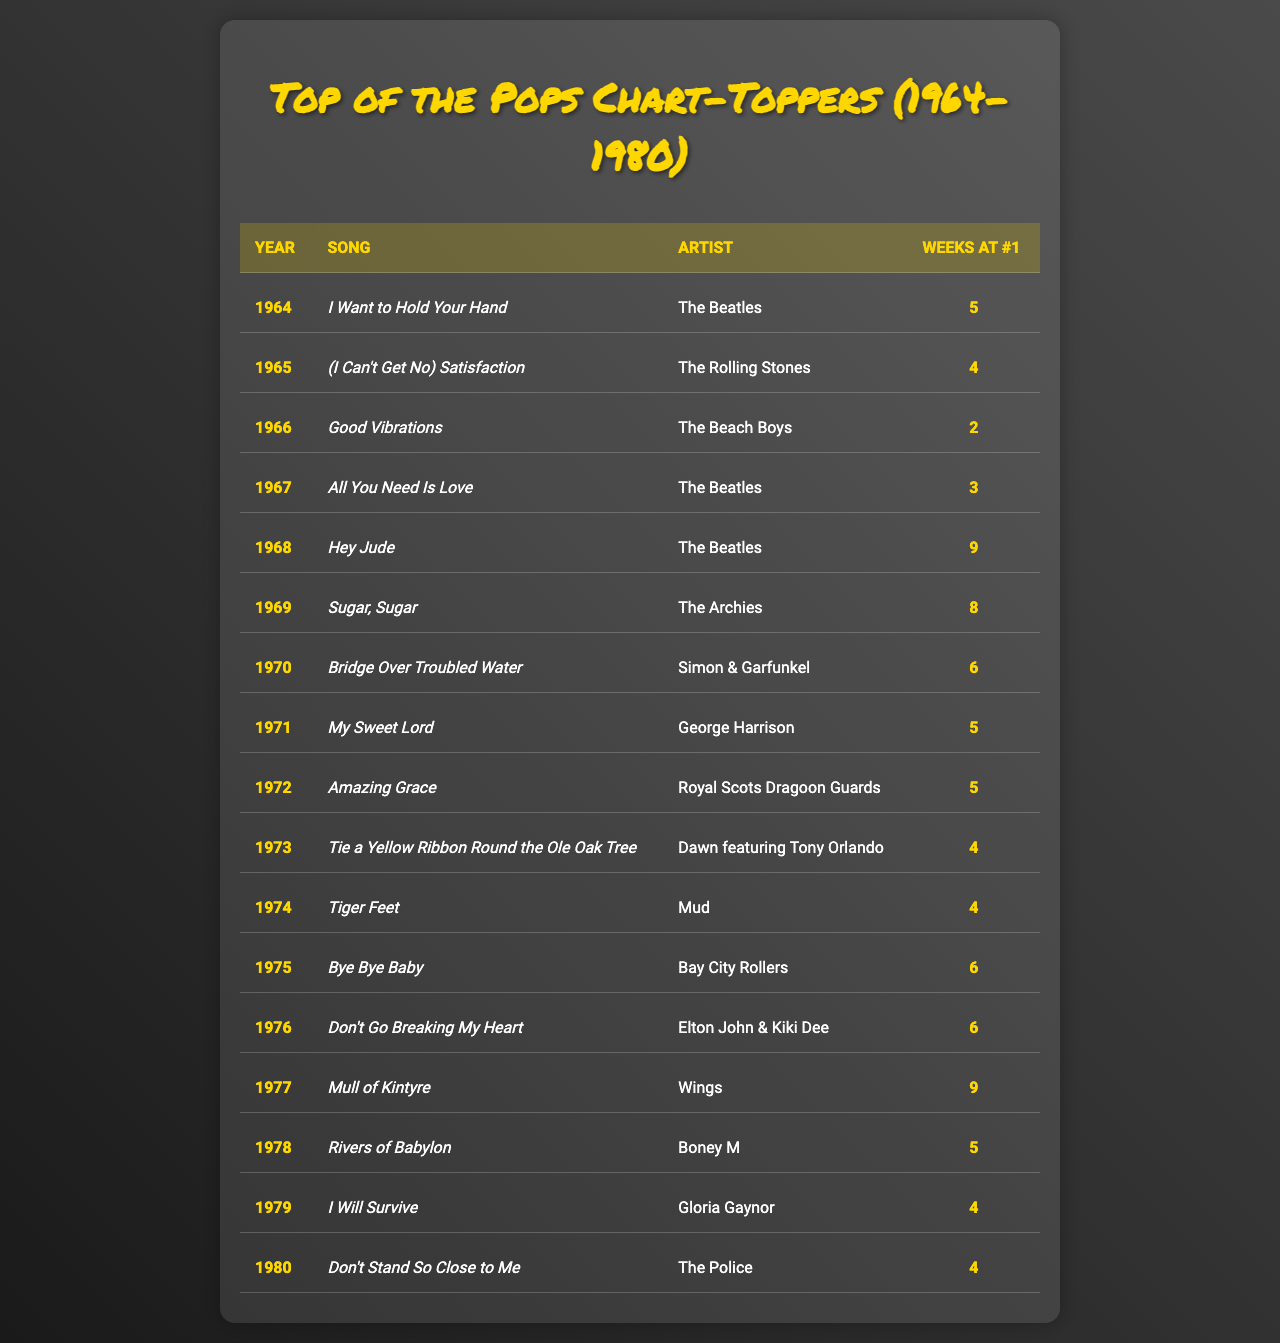What song topped the charts in 1968? We look at the row for the year 1968 in the table to find the song listed there. The song in that entry is "Hey Jude."
Answer: Hey Jude How many weeks did "I Want to Hold Your Hand" stay at number one? To find this, we examine the entry for the year 1964, where this song is listed, and check the "Weeks at #1" column, which shows it was 5 weeks.
Answer: 5 Who is the artist of the song "Good Vibrations"? We look for the entry with the song "Good Vibrations" and find the artist listed next to this song. The artist is "The Beach Boys."
Answer: The Beach Boys Which song had the most weeks at number one in 1969? In 1969, we check the data row and see that "Sugar, Sugar" is the only song listed for that year, having 8 weeks at number one.
Answer: Sugar, Sugar What is the average number of weeks at number one for all songs from 1974 to 1979? We sum the weeks at number one for each entry from 1974 to 1979, which are 4 (Tiger Feet), 6 (Bye Bye Baby), 6 (Don't Go Breaking My Heart), 9 (Mull of Kintyre), 5 (Rivers of Babylon), 4 (I Will Survive), and 4 (Don't Stand So Close to Me), totaling 38 weeks. There are 6 songs, so the average is 38/6, which is approximately 6.33 weeks.
Answer: 6.33 Was "Hey Jude" the only song that spent 9 weeks at number one? We check the entire table for any other entries with 9 weeks at number one. Only "Hey Jude" and "Mull of Kintyre" spent 9 weeks, thus the statement is false.
Answer: No Which year saw the highest number of weeks by a single song staying at number one? By reviewing the "Weeks at #1" column, we notice that both "Hey Jude" and "Mull of Kintyre" have the highest number at 9 weeks. Thus, we identify the years 1968 and 1977 as those with the highest weeks.
Answer: 1968 and 1977 How many total different songs reached number one in 1966 and 1970 combined? In 1966, we have 1 song ("Good Vibrations") and in 1970, we also have 1 song ("Bridge Over Troubled Water"). Adding these gives us a total of 2 different songs for those years combined.
Answer: 2 Were there any artists that had more than one song in the list? We check the table for artists with multiple entries. "The Beatles" had 3 songs, and "The Police" had 1. Thus, the statement is true because they had more than 1 entry.
Answer: Yes What song had the shortest duration at number one from 1964 to 1980? We examine the "Weeks at #1" column to find the smallest number of weeks, which is 2 weeks for "Good Vibrations" (1966). Therefore, we conclude it was the shortest duration at number one.
Answer: Good Vibrations In which year did "Tie a Yellow Ribbon Round the Ole Oak Tree" reach number one? Looking for that song in the table, we find it listed in 1973.
Answer: 1973 